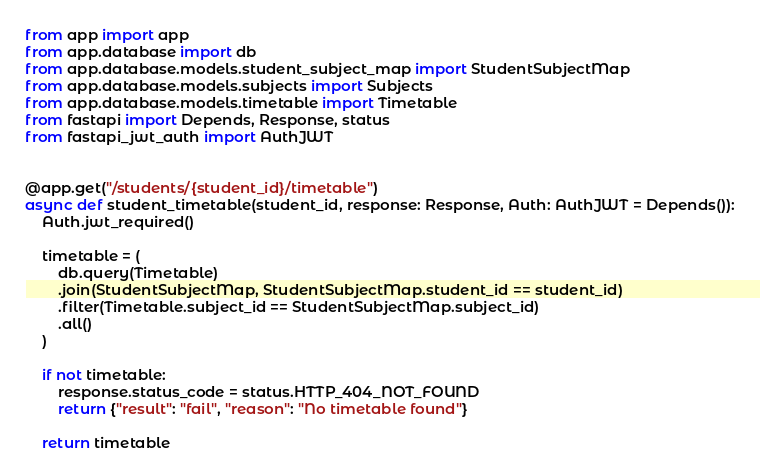Convert code to text. <code><loc_0><loc_0><loc_500><loc_500><_Python_>from app import app
from app.database import db
from app.database.models.student_subject_map import StudentSubjectMap
from app.database.models.subjects import Subjects
from app.database.models.timetable import Timetable
from fastapi import Depends, Response, status
from fastapi_jwt_auth import AuthJWT


@app.get("/students/{student_id}/timetable")
async def student_timetable(student_id, response: Response, Auth: AuthJWT = Depends()):
    Auth.jwt_required()

    timetable = (
        db.query(Timetable)
        .join(StudentSubjectMap, StudentSubjectMap.student_id == student_id)
        .filter(Timetable.subject_id == StudentSubjectMap.subject_id)
        .all()
    )

    if not timetable:
        response.status_code = status.HTTP_404_NOT_FOUND
        return {"result": "fail", "reason": "No timetable found"}

    return timetable
</code> 